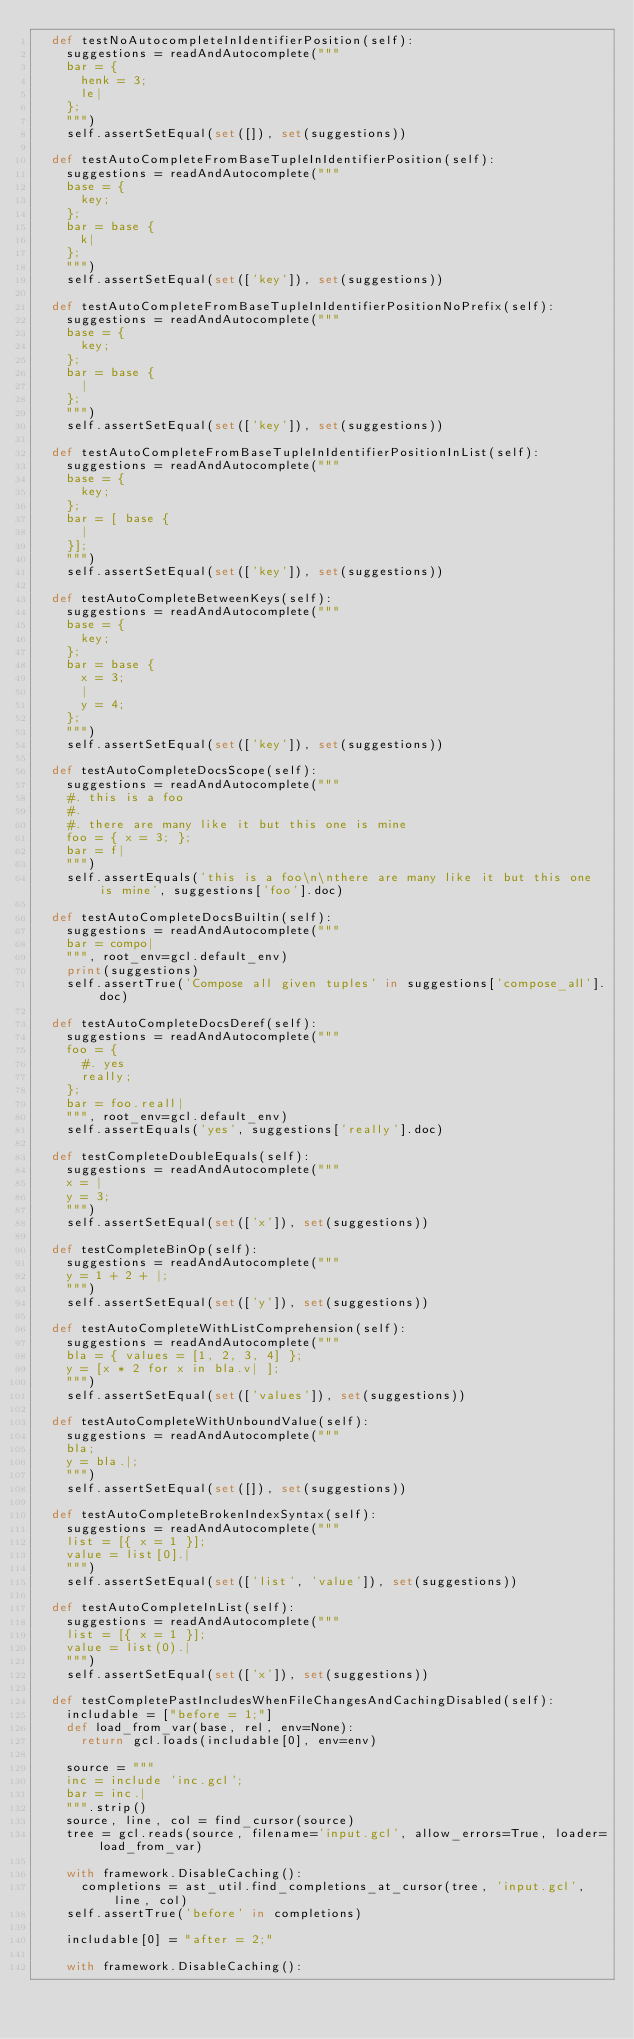Convert code to text. <code><loc_0><loc_0><loc_500><loc_500><_Python_>  def testNoAutocompleteInIdentifierPosition(self):
    suggestions = readAndAutocomplete("""
    bar = {
      henk = 3;
      le|
    };
    """)
    self.assertSetEqual(set([]), set(suggestions))

  def testAutoCompleteFromBaseTupleInIdentifierPosition(self):
    suggestions = readAndAutocomplete("""
    base = {
      key;
    };
    bar = base {
      k|
    };
    """)
    self.assertSetEqual(set(['key']), set(suggestions))

  def testAutoCompleteFromBaseTupleInIdentifierPositionNoPrefix(self):
    suggestions = readAndAutocomplete("""
    base = {
      key;
    };
    bar = base {
      |
    };
    """)
    self.assertSetEqual(set(['key']), set(suggestions))

  def testAutoCompleteFromBaseTupleInIdentifierPositionInList(self):
    suggestions = readAndAutocomplete("""
    base = {
      key;
    };
    bar = [ base {
      |
    }];
    """)
    self.assertSetEqual(set(['key']), set(suggestions))

  def testAutoCompleteBetweenKeys(self):
    suggestions = readAndAutocomplete("""
    base = {
      key;
    };
    bar = base {
      x = 3;
      |
      y = 4;
    };
    """)
    self.assertSetEqual(set(['key']), set(suggestions))

  def testAutoCompleteDocsScope(self):
    suggestions = readAndAutocomplete("""
    #. this is a foo
    #.
    #. there are many like it but this one is mine
    foo = { x = 3; };
    bar = f|
    """)
    self.assertEquals('this is a foo\n\nthere are many like it but this one is mine', suggestions['foo'].doc)

  def testAutoCompleteDocsBuiltin(self):
    suggestions = readAndAutocomplete("""
    bar = compo|
    """, root_env=gcl.default_env)
    print(suggestions)
    self.assertTrue('Compose all given tuples' in suggestions['compose_all'].doc)

  def testAutoCompleteDocsDeref(self):
    suggestions = readAndAutocomplete("""
    foo = {
      #. yes
      really;
    };
    bar = foo.reall|
    """, root_env=gcl.default_env)
    self.assertEquals('yes', suggestions['really'].doc)

  def testCompleteDoubleEquals(self):
    suggestions = readAndAutocomplete("""
    x = |
    y = 3;
    """)
    self.assertSetEqual(set(['x']), set(suggestions))

  def testCompleteBinOp(self):
    suggestions = readAndAutocomplete("""
    y = 1 + 2 + |;
    """)
    self.assertSetEqual(set(['y']), set(suggestions))

  def testAutoCompleteWithListComprehension(self):
    suggestions = readAndAutocomplete("""
    bla = { values = [1, 2, 3, 4] };
    y = [x * 2 for x in bla.v| ];
    """)
    self.assertSetEqual(set(['values']), set(suggestions))

  def testAutoCompleteWithUnboundValue(self):
    suggestions = readAndAutocomplete("""
    bla;
    y = bla.|;
    """)
    self.assertSetEqual(set([]), set(suggestions))

  def testAutoCompleteBrokenIndexSyntax(self):
    suggestions = readAndAutocomplete("""
    list = [{ x = 1 }];
    value = list[0].|
    """)
    self.assertSetEqual(set(['list', 'value']), set(suggestions))

  def testAutoCompleteInList(self):
    suggestions = readAndAutocomplete("""
    list = [{ x = 1 }];
    value = list(0).|
    """)
    self.assertSetEqual(set(['x']), set(suggestions))

  def testCompletePastIncludesWhenFileChangesAndCachingDisabled(self):
    includable = ["before = 1;"]
    def load_from_var(base, rel, env=None):
      return gcl.loads(includable[0], env=env)

    source = """
    inc = include 'inc.gcl';
    bar = inc.|
    """.strip()
    source, line, col = find_cursor(source)
    tree = gcl.reads(source, filename='input.gcl', allow_errors=True, loader=load_from_var)

    with framework.DisableCaching():
      completions = ast_util.find_completions_at_cursor(tree, 'input.gcl', line, col)
    self.assertTrue('before' in completions)

    includable[0] = "after = 2;"

    with framework.DisableCaching():</code> 